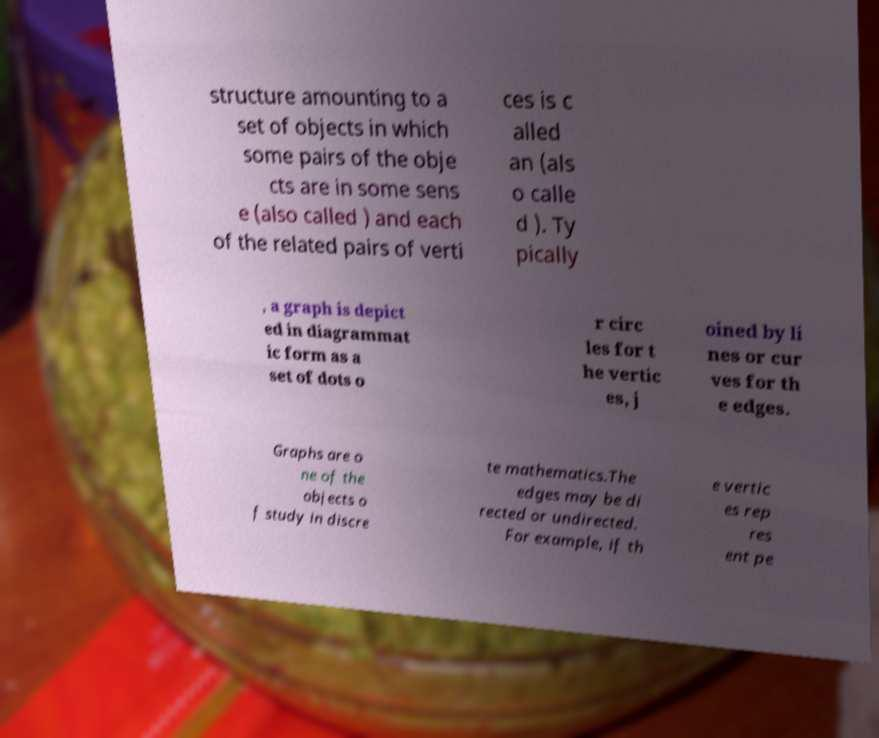Please identify and transcribe the text found in this image. structure amounting to a set of objects in which some pairs of the obje cts are in some sens e (also called ) and each of the related pairs of verti ces is c alled an (als o calle d ). Ty pically , a graph is depict ed in diagrammat ic form as a set of dots o r circ les for t he vertic es, j oined by li nes or cur ves for th e edges. Graphs are o ne of the objects o f study in discre te mathematics.The edges may be di rected or undirected. For example, if th e vertic es rep res ent pe 